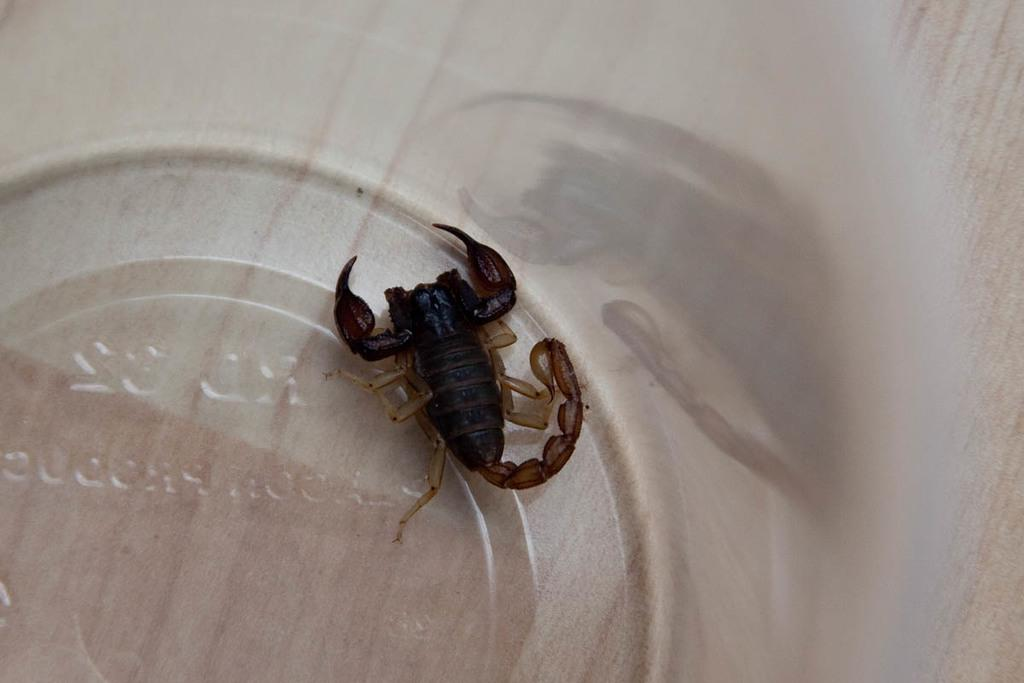What is the main subject of the picture? The main subject of the picture is a scorpion. Can you describe the color of the scorpion? The scorpion is black in color. What can be seen in the background of the image? The background of the image is white and blurred. What type of tub is visible in the image? There is no tub present in the image; it features a black scorpion on a white background. What kind of earth can be seen in the image? There is no earth visible in the image; it features a black scorpion on a white background. 